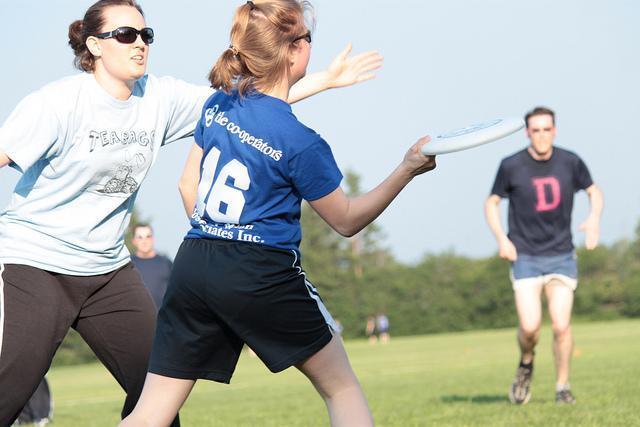How many people are wearing shorts?
Give a very brief answer. 2. How many people are visible?
Give a very brief answer. 3. 